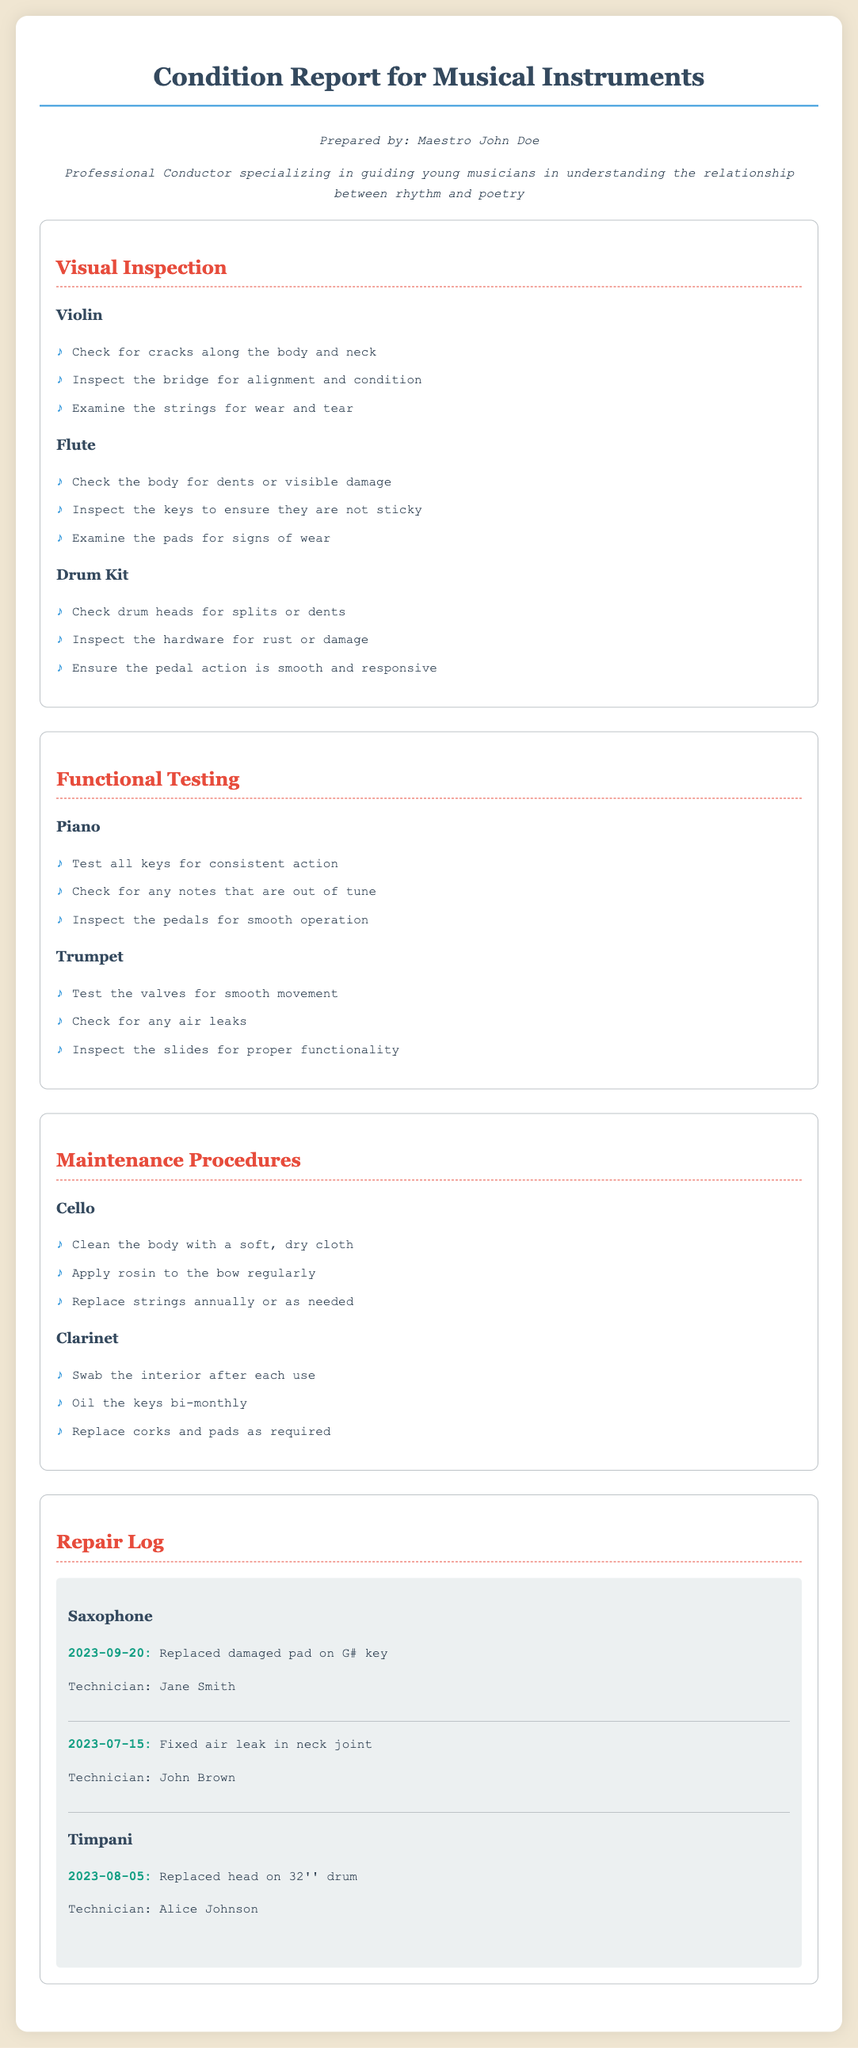What is the name of the conductor? The conductor's name is mentioned in the document's introduction section.
Answer: Maestro John Doe Which instrument has a maintenance procedure to apply rosin to the bow? The maintenance procedure section lists activities for each instrument. The activity in question relates to the Cello.
Answer: Cello What is the date when the saxophone pad was replaced? The repair log provides specific dates for each repair done on instruments.
Answer: 2023-09-20 Who replaced the head on the timpani drum? The repair log lists the name of the technician who performed the repair.
Answer: Alice Johnson How many valves does the trumpet have? The functional testing section mentions testing the valves, which implies standard features.
Answer: Not specified in the document What is inspected on the flute to ensure it works properly? The visual inspection section outlines checks for each instrument, including the flute.
Answer: Keys What is required bi-monthly for the clarinet? The maintenance procedures provide information about regular tasks required for instrument care.
Answer: Oil the keys Which instrument had an air leak fixed? The repair log details the repairs done on specific instruments, indicating the one with the issue.
Answer: Saxophone What inspection is done on the drum kit? The visual inspection section includes specific checks for the drum kit.
Answer: Drum heads 